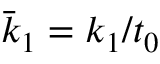<formula> <loc_0><loc_0><loc_500><loc_500>\bar { k } _ { 1 } = k _ { 1 } / t _ { 0 }</formula> 